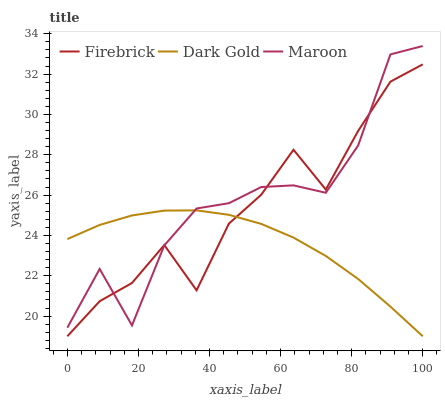Does Dark Gold have the minimum area under the curve?
Answer yes or no. Yes. Does Maroon have the maximum area under the curve?
Answer yes or no. Yes. Does Maroon have the minimum area under the curve?
Answer yes or no. No. Does Dark Gold have the maximum area under the curve?
Answer yes or no. No. Is Dark Gold the smoothest?
Answer yes or no. Yes. Is Maroon the roughest?
Answer yes or no. Yes. Is Maroon the smoothest?
Answer yes or no. No. Is Dark Gold the roughest?
Answer yes or no. No. Does Firebrick have the lowest value?
Answer yes or no. Yes. Does Maroon have the lowest value?
Answer yes or no. No. Does Maroon have the highest value?
Answer yes or no. Yes. Does Dark Gold have the highest value?
Answer yes or no. No. Does Maroon intersect Dark Gold?
Answer yes or no. Yes. Is Maroon less than Dark Gold?
Answer yes or no. No. Is Maroon greater than Dark Gold?
Answer yes or no. No. 